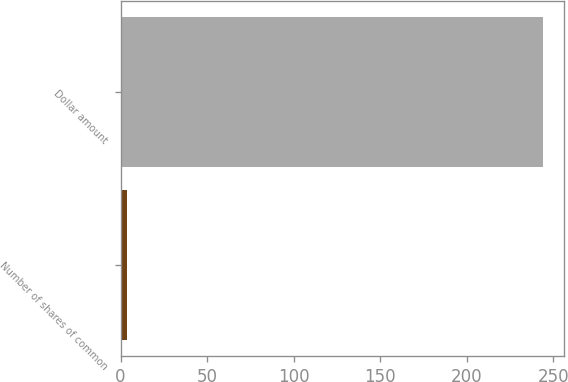Convert chart. <chart><loc_0><loc_0><loc_500><loc_500><bar_chart><fcel>Number of shares of common<fcel>Dollar amount<nl><fcel>3.6<fcel>244.3<nl></chart> 